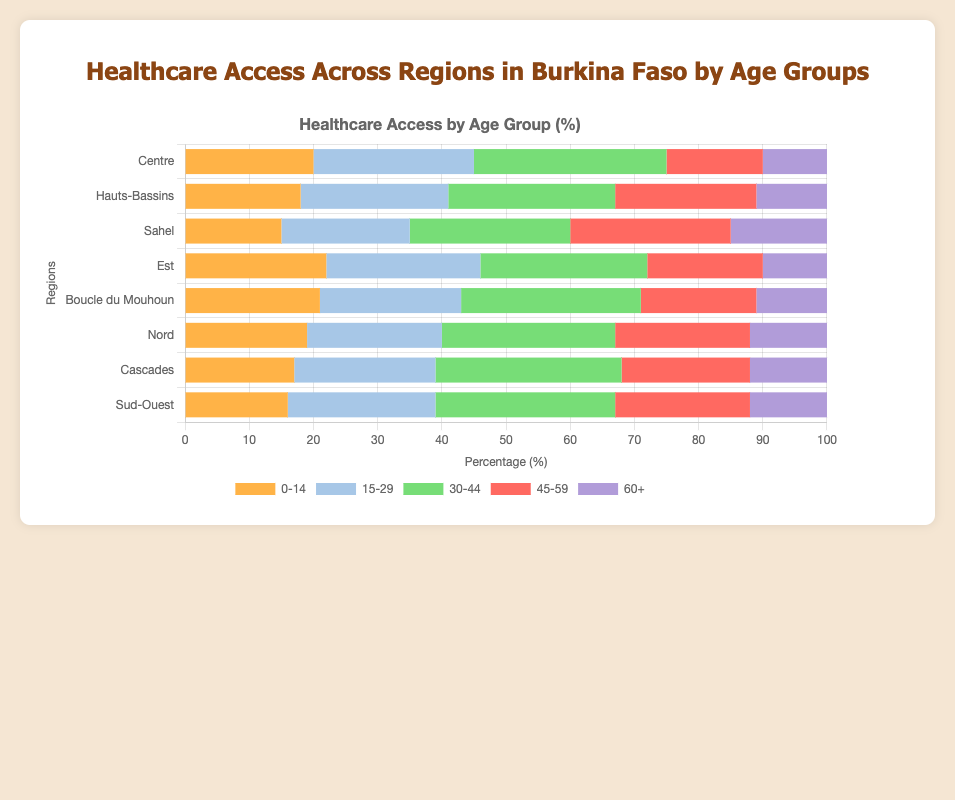What region has the highest percentage of healthcare access for the age group 30-44? In the chart, the 30-44 age group is represented with a green color bar. By visually inspecting the lengths of these green bars, the region with the longest green bar will have the highest percentage.
Answer: Centre Which region has the lowest percentage of healthcare access for the age group 0-14? The 0-14 age group is represented by orange bars. By examining the lengths of the orange bars, the shortest one identifies the region with the lowest percentage.
Answer: Sahel What is the total percentage of healthcare access for the age group 45-59 in Sahel and Est? For this, locate the red bars representing the 45-59 age group in both Sahel and Est. Add the percentages: Sahel (25%) and Est (18%).
Answer: 43% Compare the healthcare access for the age group 15-29 between Sud-Ouest and Cascades. Which region has a higher percentage? The age group 15-29 is shown with blue bars. By comparing the lengths of the blue bars for Sud-Ouest and Cascades, determine which is longer.
Answer: Sud-Ouest Across all regions, which age group consistently has the lowest percentage of healthcare access? By looking across all the regions, identify which color is consistently the shortest across each bar stack. The purple bars representing age group 60+ are the shortest overall.
Answer: 60+ Which region has the most evenly distributed healthcare access across all age groups? To determine even distribution, compare the relative lengths of the bars within each stack. The stacks without significant differences between bar lengths will be most even.
Answer: Hauts-Bassins What's the combined percentage of healthcare access for the 0-14 and 60+ age groups in Boucle du Mouhoun? Identify the lengths of orange (0-14) and purple (60+) bars in Boucle du Mouhoun and sum them: 0-14 (21%) + 60+ (11%).
Answer: 32% By comparing the total lengths of all bars in each region, which region appears to have the highest overall healthcare access? Summing the lengths of all bars per each region, the region with the longest combined bar stack will indicate the highest access.
Answer: Centre How much more healthcare access does the 30-44 age group have in Nord compared to Cascades? Locate the green bars representing the 30-44 age group in Nord and Cascades, calculate the difference: Nord (27%) - Cascades (29%).
Answer: -2% Which age group in the Sud-Ouest region receives the second-highest healthcare access? In the Sud-Ouest region's bar stack, identify the second longest bar. The green bar for the 30-44 age group is the longest, followed by the blue bar for age group 15-29.
Answer: 15-29 